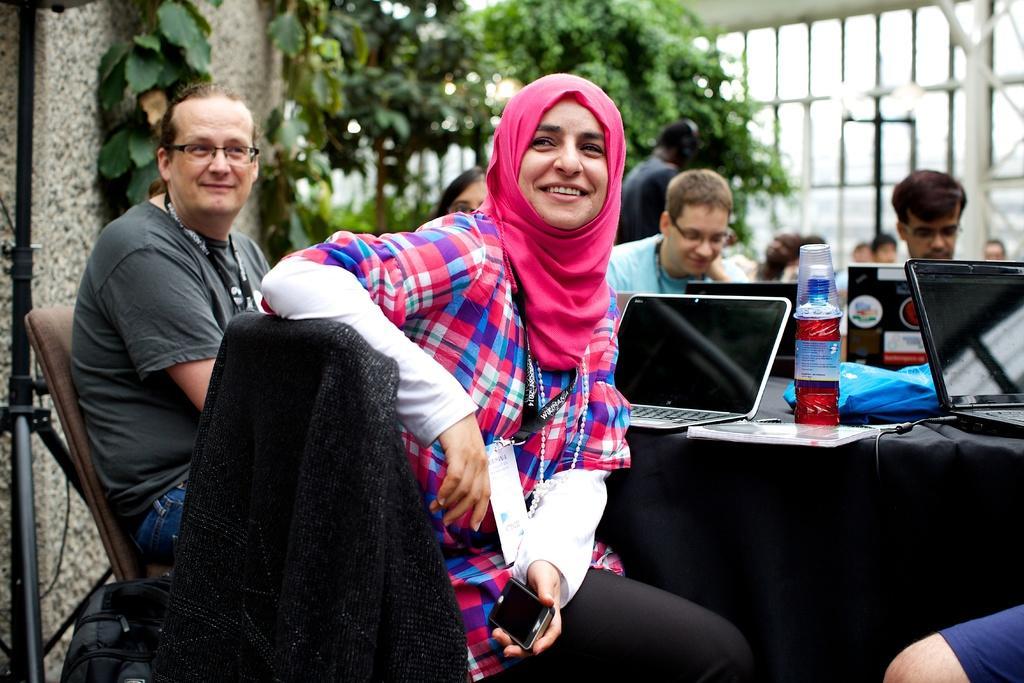Please provide a concise description of this image. In the image we can see there are many people sitting and one is standing, they are wearing clothes, identity cards and some of them are wearing spectacles. There are even chairs and a table, on the table, we can see electronic devices, bottle and other things. Here we can see trees, fence and the background is slightly blurred. 